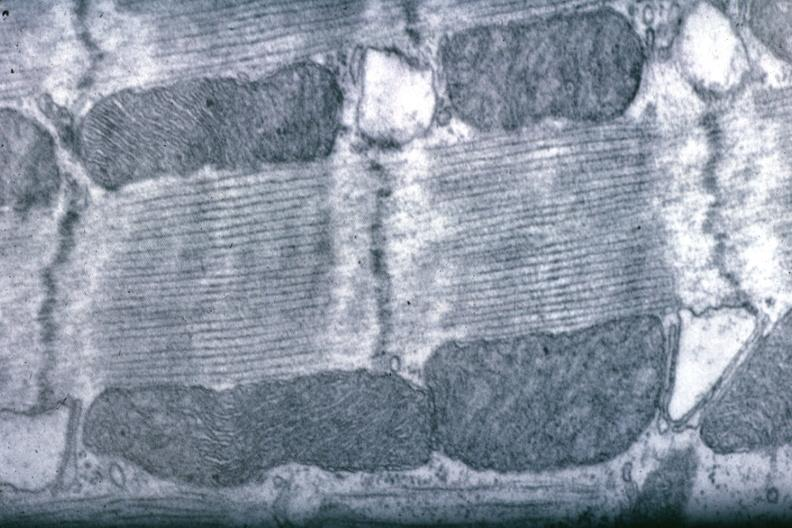what is present?
Answer the question using a single word or phrase. Cardiovascular 